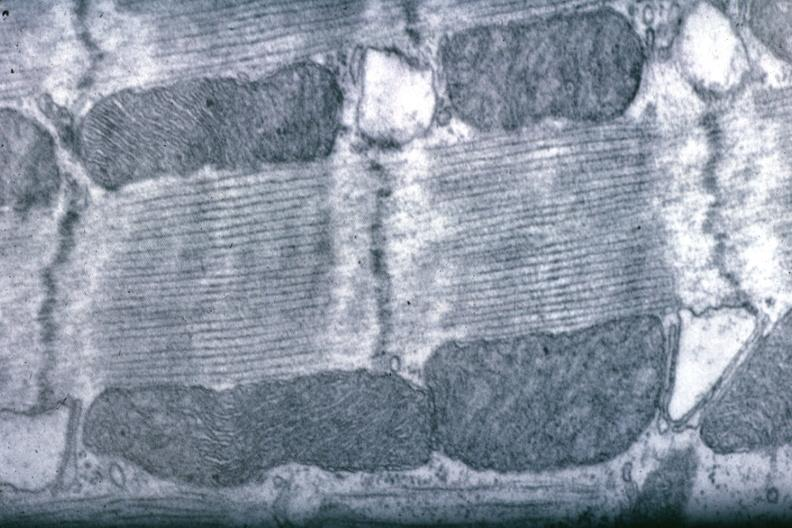what is present?
Answer the question using a single word or phrase. Cardiovascular 